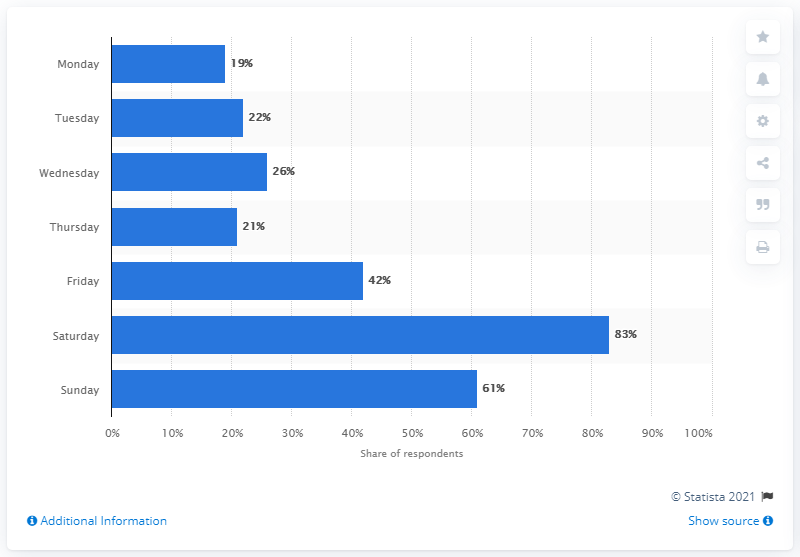Give some essential details in this illustration. It is likely that the most frequent day to have sexual intercourse in Italy in 2016 was Saturday. 